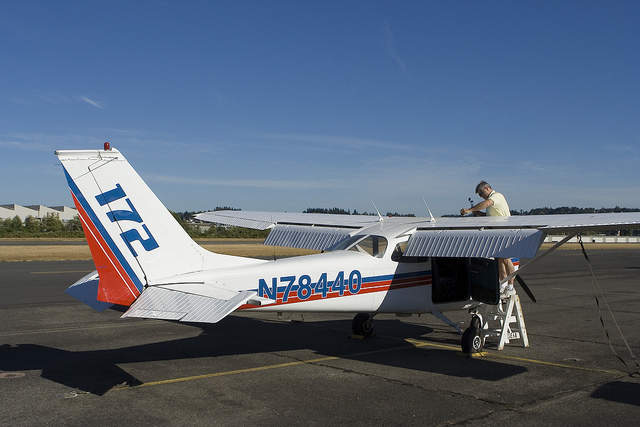<image>What is the brand of plane? It is unclear what the brand of the plane is. It could be a Cessna, a Smithfield, a Biplane, or a 172. What is the brand of plane? It is unknown what the brand of the plane is. However, it may be a biplane, a Cessna, or a Smithfield plane. 